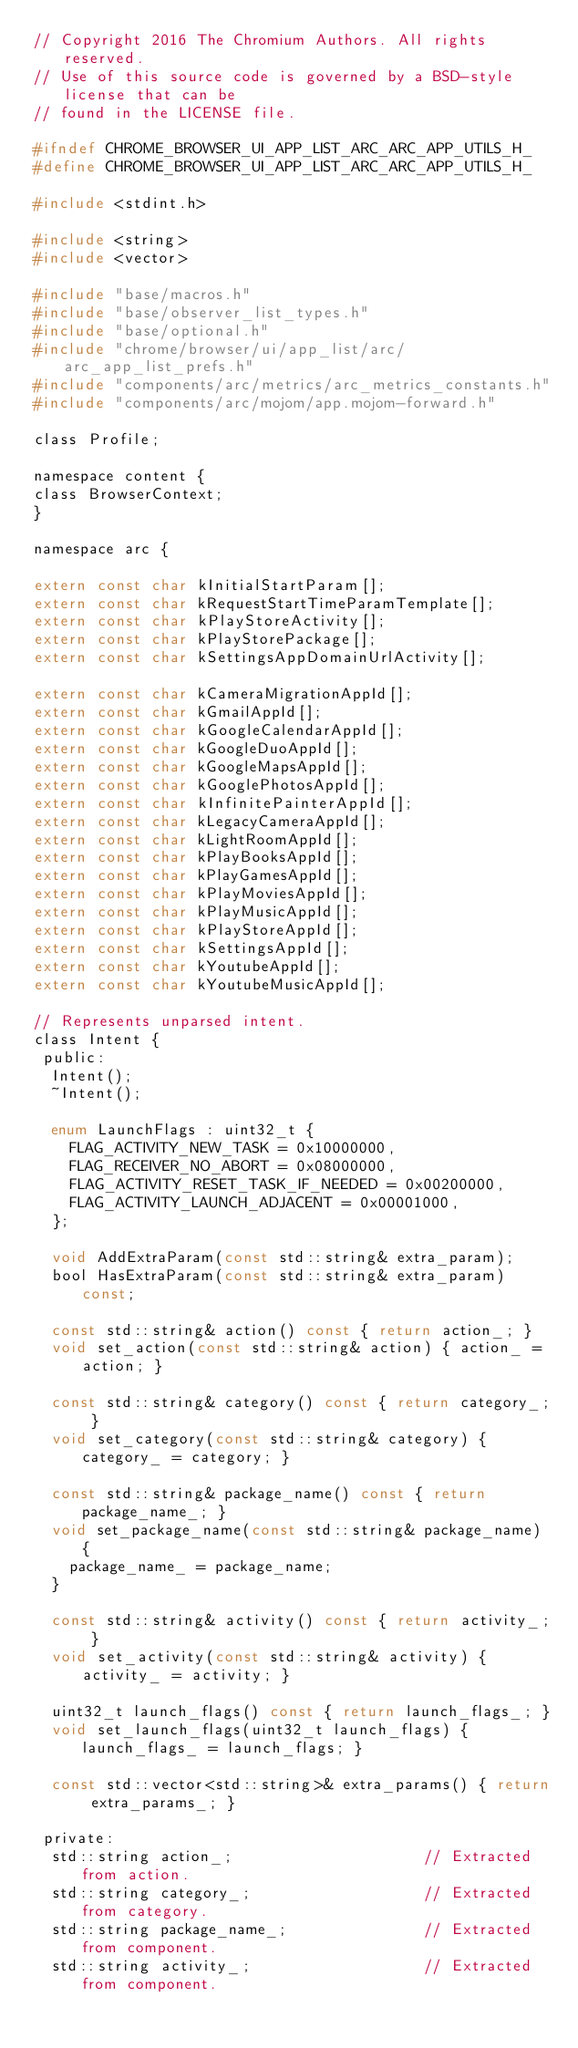<code> <loc_0><loc_0><loc_500><loc_500><_C_>// Copyright 2016 The Chromium Authors. All rights reserved.
// Use of this source code is governed by a BSD-style license that can be
// found in the LICENSE file.

#ifndef CHROME_BROWSER_UI_APP_LIST_ARC_ARC_APP_UTILS_H_
#define CHROME_BROWSER_UI_APP_LIST_ARC_ARC_APP_UTILS_H_

#include <stdint.h>

#include <string>
#include <vector>

#include "base/macros.h"
#include "base/observer_list_types.h"
#include "base/optional.h"
#include "chrome/browser/ui/app_list/arc/arc_app_list_prefs.h"
#include "components/arc/metrics/arc_metrics_constants.h"
#include "components/arc/mojom/app.mojom-forward.h"

class Profile;

namespace content {
class BrowserContext;
}

namespace arc {

extern const char kInitialStartParam[];
extern const char kRequestStartTimeParamTemplate[];
extern const char kPlayStoreActivity[];
extern const char kPlayStorePackage[];
extern const char kSettingsAppDomainUrlActivity[];

extern const char kCameraMigrationAppId[];
extern const char kGmailAppId[];
extern const char kGoogleCalendarAppId[];
extern const char kGoogleDuoAppId[];
extern const char kGoogleMapsAppId[];
extern const char kGooglePhotosAppId[];
extern const char kInfinitePainterAppId[];
extern const char kLegacyCameraAppId[];
extern const char kLightRoomAppId[];
extern const char kPlayBooksAppId[];
extern const char kPlayGamesAppId[];
extern const char kPlayMoviesAppId[];
extern const char kPlayMusicAppId[];
extern const char kPlayStoreAppId[];
extern const char kSettingsAppId[];
extern const char kYoutubeAppId[];
extern const char kYoutubeMusicAppId[];

// Represents unparsed intent.
class Intent {
 public:
  Intent();
  ~Intent();

  enum LaunchFlags : uint32_t {
    FLAG_ACTIVITY_NEW_TASK = 0x10000000,
    FLAG_RECEIVER_NO_ABORT = 0x08000000,
    FLAG_ACTIVITY_RESET_TASK_IF_NEEDED = 0x00200000,
    FLAG_ACTIVITY_LAUNCH_ADJACENT = 0x00001000,
  };

  void AddExtraParam(const std::string& extra_param);
  bool HasExtraParam(const std::string& extra_param) const;

  const std::string& action() const { return action_; }
  void set_action(const std::string& action) { action_ = action; }

  const std::string& category() const { return category_; }
  void set_category(const std::string& category) { category_ = category; }

  const std::string& package_name() const { return package_name_; }
  void set_package_name(const std::string& package_name) {
    package_name_ = package_name;
  }

  const std::string& activity() const { return activity_; }
  void set_activity(const std::string& activity) { activity_ = activity; }

  uint32_t launch_flags() const { return launch_flags_; }
  void set_launch_flags(uint32_t launch_flags) { launch_flags_ = launch_flags; }

  const std::vector<std::string>& extra_params() { return extra_params_; }

 private:
  std::string action_;                     // Extracted from action.
  std::string category_;                   // Extracted from category.
  std::string package_name_;               // Extracted from component.
  std::string activity_;                   // Extracted from component.</code> 